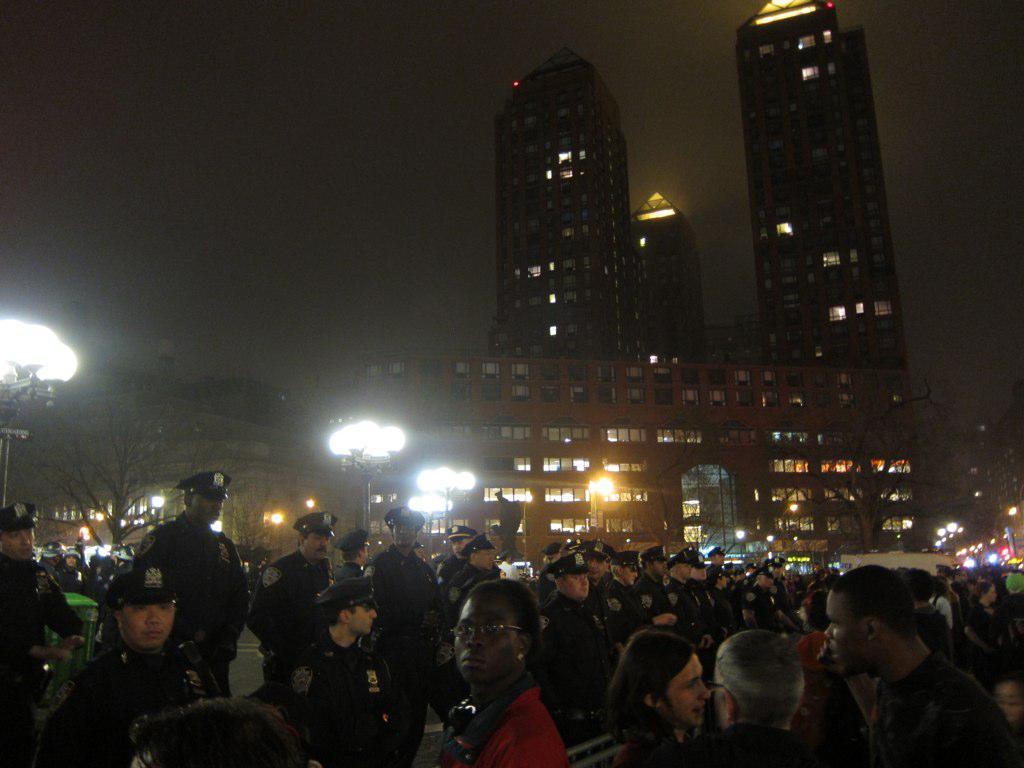Please provide a concise description of this image. This is a image of the busy street where we can see there are so many people on the road, behind them there is a building and some lights on the pole. 